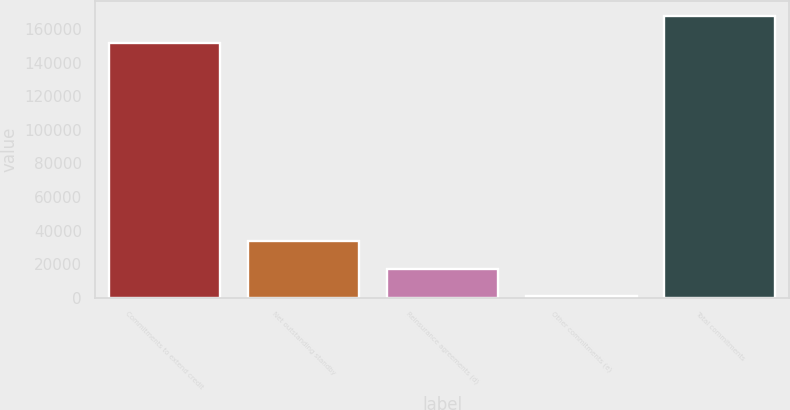Convert chart to OTSL. <chart><loc_0><loc_0><loc_500><loc_500><bar_chart><fcel>Commitments to extend credit<fcel>Net outstanding standby<fcel>Reinsurance agreements (d)<fcel>Other commitments (e)<fcel>Total commitments<nl><fcel>151981<fcel>33553<fcel>17260<fcel>967<fcel>168274<nl></chart> 